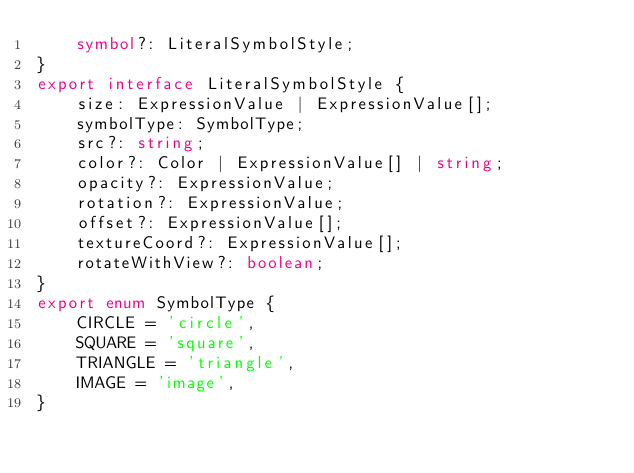Convert code to text. <code><loc_0><loc_0><loc_500><loc_500><_TypeScript_>    symbol?: LiteralSymbolStyle;
}
export interface LiteralSymbolStyle {
    size: ExpressionValue | ExpressionValue[];
    symbolType: SymbolType;
    src?: string;
    color?: Color | ExpressionValue[] | string;
    opacity?: ExpressionValue;
    rotation?: ExpressionValue;
    offset?: ExpressionValue[];
    textureCoord?: ExpressionValue[];
    rotateWithView?: boolean;
}
export enum SymbolType {
    CIRCLE = 'circle',
    SQUARE = 'square',
    TRIANGLE = 'triangle',
    IMAGE = 'image',
}
</code> 